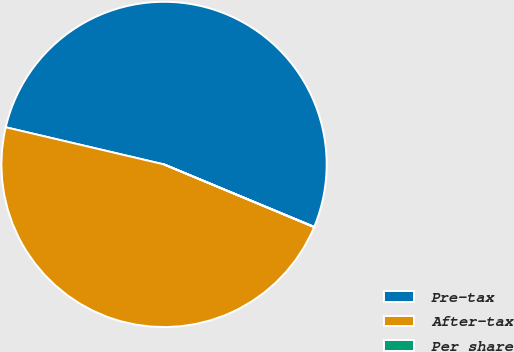Convert chart to OTSL. <chart><loc_0><loc_0><loc_500><loc_500><pie_chart><fcel>Pre-tax<fcel>After-tax<fcel>Per share<nl><fcel>52.6%<fcel>47.37%<fcel>0.03%<nl></chart> 